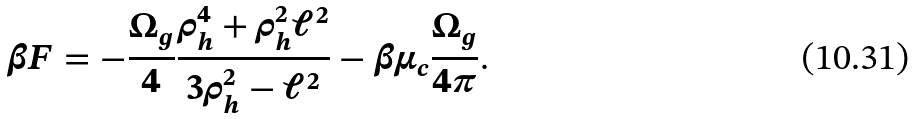<formula> <loc_0><loc_0><loc_500><loc_500>\beta F = - { \frac { \Omega _ { g } } { 4 } } { \frac { \rho _ { h } ^ { 4 } + \rho _ { h } ^ { 2 } \ell ^ { 2 } } { 3 \rho _ { h } ^ { 2 } - \ell ^ { 2 } } } - \beta \mu _ { c } { \frac { \Omega _ { g } } { 4 \pi } } .</formula> 